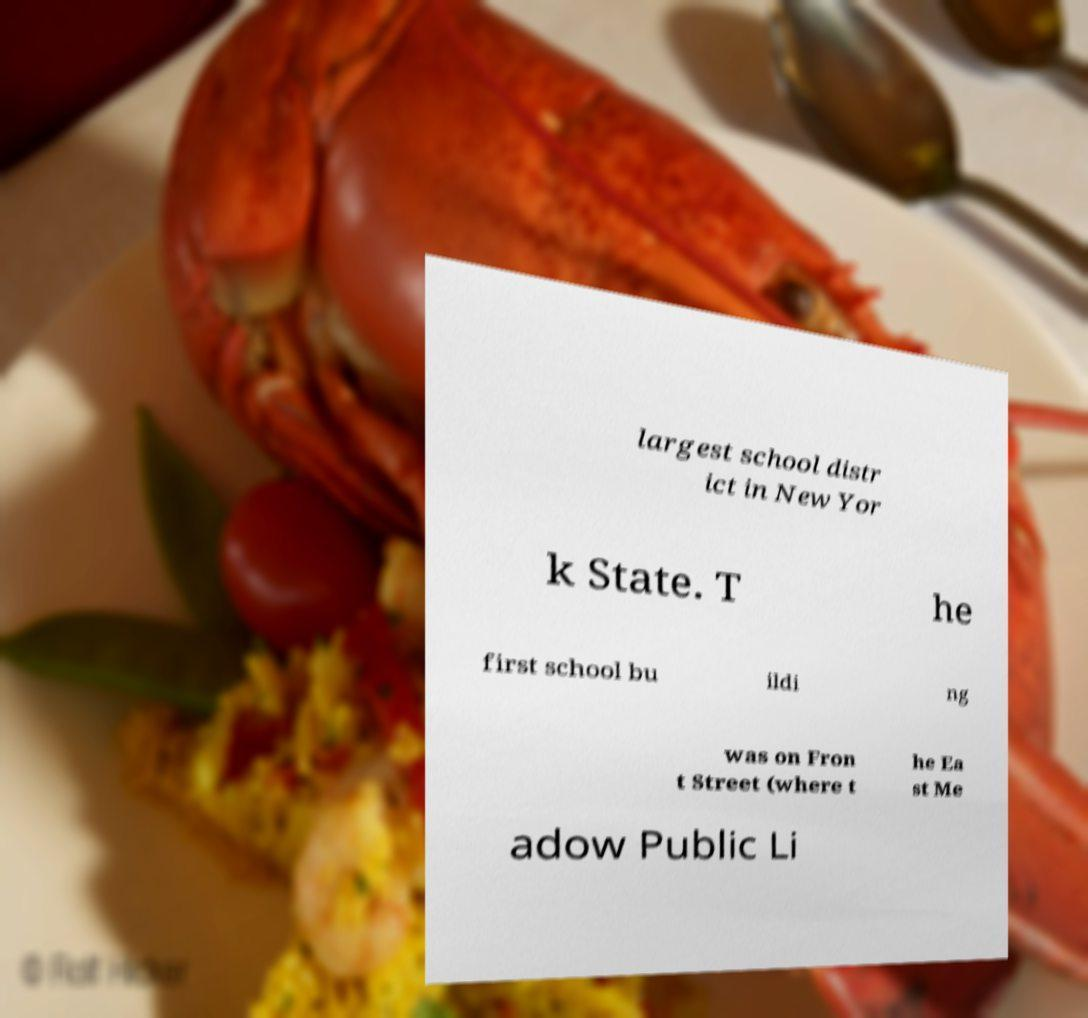Could you extract and type out the text from this image? largest school distr ict in New Yor k State. T he first school bu ildi ng was on Fron t Street (where t he Ea st Me adow Public Li 